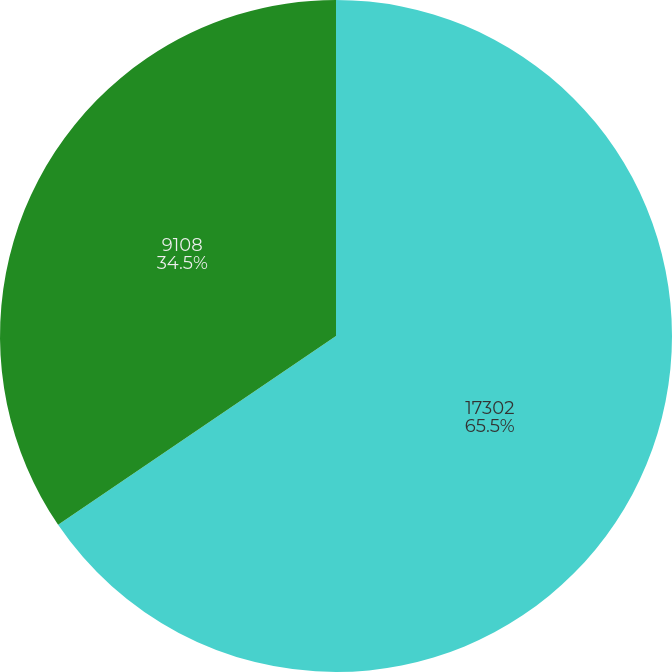Convert chart. <chart><loc_0><loc_0><loc_500><loc_500><pie_chart><fcel>17302<fcel>9108<nl><fcel>65.5%<fcel>34.5%<nl></chart> 